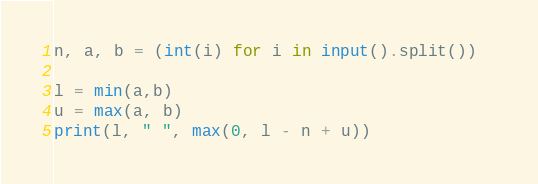<code> <loc_0><loc_0><loc_500><loc_500><_Python_>n, a, b = (int(i) for i in input().split())  

l = min(a,b)
u = max(a, b)
print(l, " ", max(0, l - n + u))</code> 